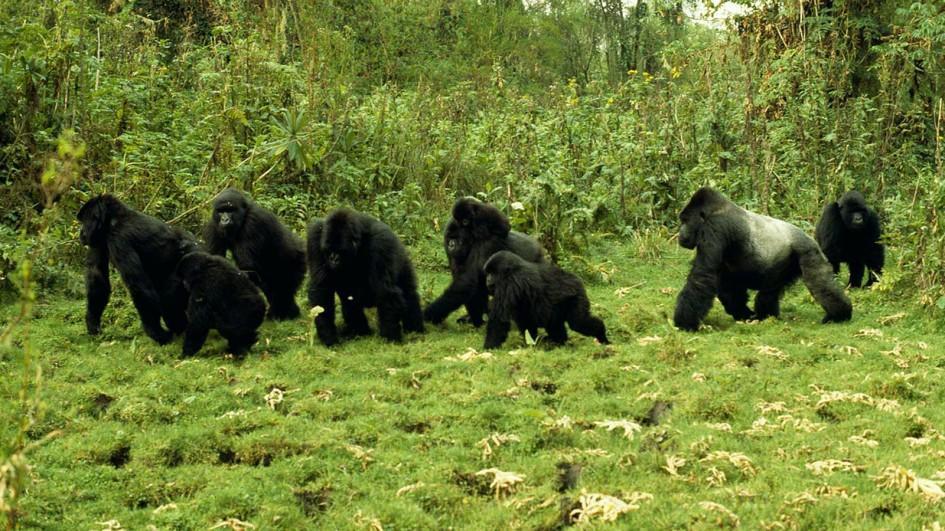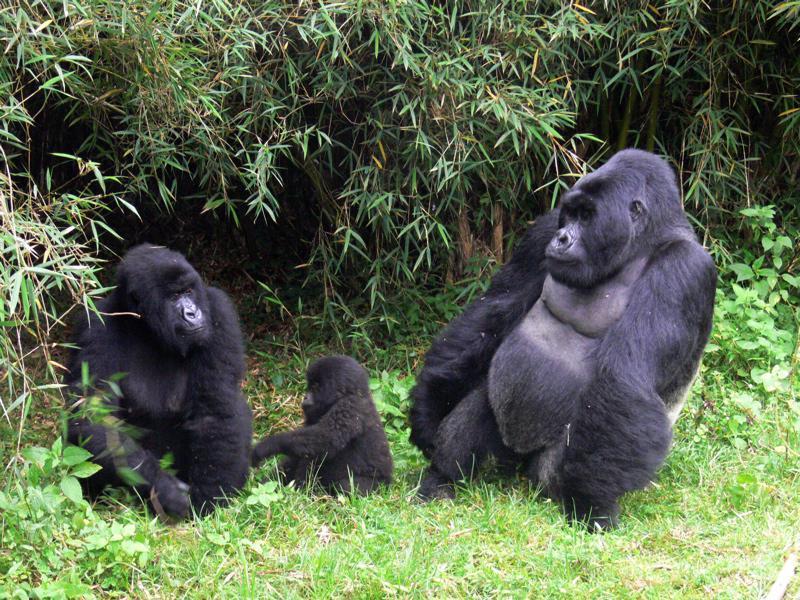The first image is the image on the left, the second image is the image on the right. Examine the images to the left and right. Is the description "A single adult gorilla is holding a baby." accurate? Answer yes or no. No. The first image is the image on the left, the second image is the image on the right. Evaluate the accuracy of this statement regarding the images: "An image shows exactly one adult gorilla in close contact with a baby gorilla.". Is it true? Answer yes or no. No. 